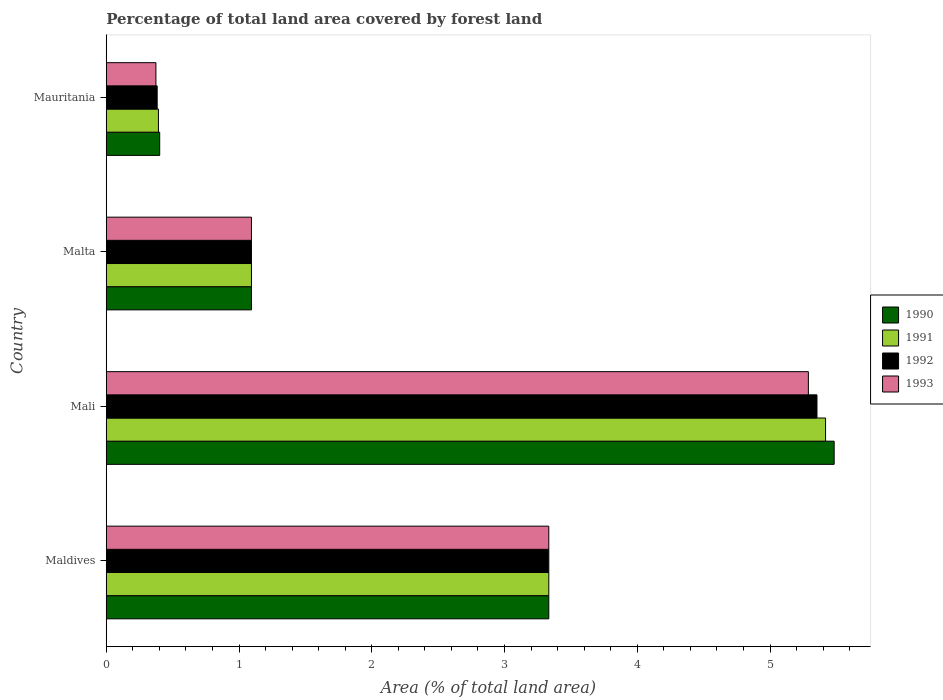How many different coloured bars are there?
Provide a short and direct response. 4. How many groups of bars are there?
Ensure brevity in your answer.  4. Are the number of bars per tick equal to the number of legend labels?
Offer a terse response. Yes. Are the number of bars on each tick of the Y-axis equal?
Give a very brief answer. Yes. How many bars are there on the 1st tick from the bottom?
Provide a succinct answer. 4. What is the label of the 3rd group of bars from the top?
Keep it short and to the point. Mali. In how many cases, is the number of bars for a given country not equal to the number of legend labels?
Provide a short and direct response. 0. What is the percentage of forest land in 1993 in Maldives?
Provide a succinct answer. 3.33. Across all countries, what is the maximum percentage of forest land in 1991?
Provide a short and direct response. 5.42. Across all countries, what is the minimum percentage of forest land in 1993?
Offer a terse response. 0.37. In which country was the percentage of forest land in 1992 maximum?
Provide a succinct answer. Mali. In which country was the percentage of forest land in 1992 minimum?
Ensure brevity in your answer.  Mauritania. What is the total percentage of forest land in 1993 in the graph?
Keep it short and to the point. 10.09. What is the difference between the percentage of forest land in 1990 in Maldives and that in Mauritania?
Make the answer very short. 2.93. What is the difference between the percentage of forest land in 1992 in Maldives and the percentage of forest land in 1990 in Mauritania?
Keep it short and to the point. 2.93. What is the average percentage of forest land in 1992 per country?
Your answer should be compact. 2.54. What is the difference between the percentage of forest land in 1993 and percentage of forest land in 1992 in Mali?
Your answer should be compact. -0.06. In how many countries, is the percentage of forest land in 1991 greater than 3.8 %?
Your answer should be compact. 1. What is the ratio of the percentage of forest land in 1992 in Malta to that in Mauritania?
Ensure brevity in your answer.  2.85. Is the percentage of forest land in 1992 in Maldives less than that in Mauritania?
Your answer should be compact. No. What is the difference between the highest and the second highest percentage of forest land in 1992?
Keep it short and to the point. 2.02. What is the difference between the highest and the lowest percentage of forest land in 1993?
Provide a short and direct response. 4.91. Is the sum of the percentage of forest land in 1992 in Mali and Malta greater than the maximum percentage of forest land in 1991 across all countries?
Provide a short and direct response. Yes. What does the 3rd bar from the top in Mali represents?
Make the answer very short. 1991. How many bars are there?
Give a very brief answer. 16. Are all the bars in the graph horizontal?
Your answer should be compact. Yes. What is the difference between two consecutive major ticks on the X-axis?
Your response must be concise. 1. Are the values on the major ticks of X-axis written in scientific E-notation?
Ensure brevity in your answer.  No. Does the graph contain grids?
Give a very brief answer. No. How many legend labels are there?
Ensure brevity in your answer.  4. How are the legend labels stacked?
Your answer should be compact. Vertical. What is the title of the graph?
Give a very brief answer. Percentage of total land area covered by forest land. Does "1970" appear as one of the legend labels in the graph?
Offer a very short reply. No. What is the label or title of the X-axis?
Give a very brief answer. Area (% of total land area). What is the label or title of the Y-axis?
Make the answer very short. Country. What is the Area (% of total land area) of 1990 in Maldives?
Make the answer very short. 3.33. What is the Area (% of total land area) in 1991 in Maldives?
Offer a very short reply. 3.33. What is the Area (% of total land area) of 1992 in Maldives?
Make the answer very short. 3.33. What is the Area (% of total land area) of 1993 in Maldives?
Provide a succinct answer. 3.33. What is the Area (% of total land area) in 1990 in Mali?
Keep it short and to the point. 5.48. What is the Area (% of total land area) in 1991 in Mali?
Keep it short and to the point. 5.42. What is the Area (% of total land area) in 1992 in Mali?
Your response must be concise. 5.35. What is the Area (% of total land area) in 1993 in Mali?
Offer a terse response. 5.29. What is the Area (% of total land area) of 1990 in Malta?
Your answer should be very brief. 1.09. What is the Area (% of total land area) in 1991 in Malta?
Give a very brief answer. 1.09. What is the Area (% of total land area) in 1992 in Malta?
Give a very brief answer. 1.09. What is the Area (% of total land area) in 1993 in Malta?
Offer a terse response. 1.09. What is the Area (% of total land area) of 1990 in Mauritania?
Ensure brevity in your answer.  0.4. What is the Area (% of total land area) in 1991 in Mauritania?
Make the answer very short. 0.39. What is the Area (% of total land area) in 1992 in Mauritania?
Ensure brevity in your answer.  0.38. What is the Area (% of total land area) of 1993 in Mauritania?
Keep it short and to the point. 0.37. Across all countries, what is the maximum Area (% of total land area) of 1990?
Offer a terse response. 5.48. Across all countries, what is the maximum Area (% of total land area) in 1991?
Provide a succinct answer. 5.42. Across all countries, what is the maximum Area (% of total land area) of 1992?
Make the answer very short. 5.35. Across all countries, what is the maximum Area (% of total land area) of 1993?
Keep it short and to the point. 5.29. Across all countries, what is the minimum Area (% of total land area) in 1990?
Offer a terse response. 0.4. Across all countries, what is the minimum Area (% of total land area) of 1991?
Offer a terse response. 0.39. Across all countries, what is the minimum Area (% of total land area) of 1992?
Offer a terse response. 0.38. Across all countries, what is the minimum Area (% of total land area) of 1993?
Your answer should be compact. 0.37. What is the total Area (% of total land area) of 1990 in the graph?
Provide a succinct answer. 10.31. What is the total Area (% of total land area) of 1991 in the graph?
Ensure brevity in your answer.  10.24. What is the total Area (% of total land area) in 1992 in the graph?
Keep it short and to the point. 10.16. What is the total Area (% of total land area) in 1993 in the graph?
Offer a terse response. 10.09. What is the difference between the Area (% of total land area) of 1990 in Maldives and that in Mali?
Keep it short and to the point. -2.15. What is the difference between the Area (% of total land area) of 1991 in Maldives and that in Mali?
Offer a terse response. -2.08. What is the difference between the Area (% of total land area) of 1992 in Maldives and that in Mali?
Offer a terse response. -2.02. What is the difference between the Area (% of total land area) of 1993 in Maldives and that in Mali?
Ensure brevity in your answer.  -1.96. What is the difference between the Area (% of total land area) of 1990 in Maldives and that in Malta?
Make the answer very short. 2.24. What is the difference between the Area (% of total land area) of 1991 in Maldives and that in Malta?
Make the answer very short. 2.24. What is the difference between the Area (% of total land area) of 1992 in Maldives and that in Malta?
Provide a short and direct response. 2.24. What is the difference between the Area (% of total land area) in 1993 in Maldives and that in Malta?
Make the answer very short. 2.24. What is the difference between the Area (% of total land area) in 1990 in Maldives and that in Mauritania?
Your answer should be very brief. 2.93. What is the difference between the Area (% of total land area) of 1991 in Maldives and that in Mauritania?
Make the answer very short. 2.94. What is the difference between the Area (% of total land area) in 1992 in Maldives and that in Mauritania?
Offer a terse response. 2.95. What is the difference between the Area (% of total land area) of 1993 in Maldives and that in Mauritania?
Give a very brief answer. 2.96. What is the difference between the Area (% of total land area) in 1990 in Mali and that in Malta?
Offer a very short reply. 4.39. What is the difference between the Area (% of total land area) in 1991 in Mali and that in Malta?
Keep it short and to the point. 4.32. What is the difference between the Area (% of total land area) in 1992 in Mali and that in Malta?
Offer a terse response. 4.26. What is the difference between the Area (% of total land area) of 1993 in Mali and that in Malta?
Ensure brevity in your answer.  4.19. What is the difference between the Area (% of total land area) in 1990 in Mali and that in Mauritania?
Give a very brief answer. 5.08. What is the difference between the Area (% of total land area) in 1991 in Mali and that in Mauritania?
Provide a succinct answer. 5.02. What is the difference between the Area (% of total land area) of 1992 in Mali and that in Mauritania?
Provide a succinct answer. 4.97. What is the difference between the Area (% of total land area) of 1993 in Mali and that in Mauritania?
Offer a terse response. 4.91. What is the difference between the Area (% of total land area) of 1990 in Malta and that in Mauritania?
Keep it short and to the point. 0.69. What is the difference between the Area (% of total land area) of 1991 in Malta and that in Mauritania?
Make the answer very short. 0.7. What is the difference between the Area (% of total land area) of 1992 in Malta and that in Mauritania?
Provide a short and direct response. 0.71. What is the difference between the Area (% of total land area) of 1993 in Malta and that in Mauritania?
Offer a terse response. 0.72. What is the difference between the Area (% of total land area) of 1990 in Maldives and the Area (% of total land area) of 1991 in Mali?
Offer a very short reply. -2.08. What is the difference between the Area (% of total land area) in 1990 in Maldives and the Area (% of total land area) in 1992 in Mali?
Give a very brief answer. -2.02. What is the difference between the Area (% of total land area) of 1990 in Maldives and the Area (% of total land area) of 1993 in Mali?
Give a very brief answer. -1.96. What is the difference between the Area (% of total land area) in 1991 in Maldives and the Area (% of total land area) in 1992 in Mali?
Ensure brevity in your answer.  -2.02. What is the difference between the Area (% of total land area) in 1991 in Maldives and the Area (% of total land area) in 1993 in Mali?
Offer a terse response. -1.96. What is the difference between the Area (% of total land area) of 1992 in Maldives and the Area (% of total land area) of 1993 in Mali?
Your response must be concise. -1.96. What is the difference between the Area (% of total land area) of 1990 in Maldives and the Area (% of total land area) of 1991 in Malta?
Ensure brevity in your answer.  2.24. What is the difference between the Area (% of total land area) of 1990 in Maldives and the Area (% of total land area) of 1992 in Malta?
Your answer should be very brief. 2.24. What is the difference between the Area (% of total land area) of 1990 in Maldives and the Area (% of total land area) of 1993 in Malta?
Make the answer very short. 2.24. What is the difference between the Area (% of total land area) of 1991 in Maldives and the Area (% of total land area) of 1992 in Malta?
Your answer should be very brief. 2.24. What is the difference between the Area (% of total land area) of 1991 in Maldives and the Area (% of total land area) of 1993 in Malta?
Offer a terse response. 2.24. What is the difference between the Area (% of total land area) of 1992 in Maldives and the Area (% of total land area) of 1993 in Malta?
Your answer should be compact. 2.24. What is the difference between the Area (% of total land area) of 1990 in Maldives and the Area (% of total land area) of 1991 in Mauritania?
Offer a very short reply. 2.94. What is the difference between the Area (% of total land area) of 1990 in Maldives and the Area (% of total land area) of 1992 in Mauritania?
Ensure brevity in your answer.  2.95. What is the difference between the Area (% of total land area) of 1990 in Maldives and the Area (% of total land area) of 1993 in Mauritania?
Provide a succinct answer. 2.96. What is the difference between the Area (% of total land area) in 1991 in Maldives and the Area (% of total land area) in 1992 in Mauritania?
Ensure brevity in your answer.  2.95. What is the difference between the Area (% of total land area) of 1991 in Maldives and the Area (% of total land area) of 1993 in Mauritania?
Offer a terse response. 2.96. What is the difference between the Area (% of total land area) of 1992 in Maldives and the Area (% of total land area) of 1993 in Mauritania?
Offer a terse response. 2.96. What is the difference between the Area (% of total land area) in 1990 in Mali and the Area (% of total land area) in 1991 in Malta?
Offer a terse response. 4.39. What is the difference between the Area (% of total land area) of 1990 in Mali and the Area (% of total land area) of 1992 in Malta?
Ensure brevity in your answer.  4.39. What is the difference between the Area (% of total land area) of 1990 in Mali and the Area (% of total land area) of 1993 in Malta?
Your answer should be compact. 4.39. What is the difference between the Area (% of total land area) in 1991 in Mali and the Area (% of total land area) in 1992 in Malta?
Make the answer very short. 4.32. What is the difference between the Area (% of total land area) of 1991 in Mali and the Area (% of total land area) of 1993 in Malta?
Keep it short and to the point. 4.32. What is the difference between the Area (% of total land area) of 1992 in Mali and the Area (% of total land area) of 1993 in Malta?
Ensure brevity in your answer.  4.26. What is the difference between the Area (% of total land area) in 1990 in Mali and the Area (% of total land area) in 1991 in Mauritania?
Your answer should be very brief. 5.09. What is the difference between the Area (% of total land area) of 1990 in Mali and the Area (% of total land area) of 1992 in Mauritania?
Your answer should be very brief. 5.1. What is the difference between the Area (% of total land area) in 1990 in Mali and the Area (% of total land area) in 1993 in Mauritania?
Ensure brevity in your answer.  5.11. What is the difference between the Area (% of total land area) of 1991 in Mali and the Area (% of total land area) of 1992 in Mauritania?
Your answer should be compact. 5.03. What is the difference between the Area (% of total land area) in 1991 in Mali and the Area (% of total land area) in 1993 in Mauritania?
Make the answer very short. 5.04. What is the difference between the Area (% of total land area) in 1992 in Mali and the Area (% of total land area) in 1993 in Mauritania?
Your answer should be compact. 4.98. What is the difference between the Area (% of total land area) in 1990 in Malta and the Area (% of total land area) in 1991 in Mauritania?
Make the answer very short. 0.7. What is the difference between the Area (% of total land area) in 1990 in Malta and the Area (% of total land area) in 1992 in Mauritania?
Your answer should be very brief. 0.71. What is the difference between the Area (% of total land area) in 1990 in Malta and the Area (% of total land area) in 1993 in Mauritania?
Provide a short and direct response. 0.72. What is the difference between the Area (% of total land area) in 1991 in Malta and the Area (% of total land area) in 1992 in Mauritania?
Your answer should be very brief. 0.71. What is the difference between the Area (% of total land area) in 1991 in Malta and the Area (% of total land area) in 1993 in Mauritania?
Keep it short and to the point. 0.72. What is the difference between the Area (% of total land area) of 1992 in Malta and the Area (% of total land area) of 1993 in Mauritania?
Your answer should be compact. 0.72. What is the average Area (% of total land area) of 1990 per country?
Offer a terse response. 2.58. What is the average Area (% of total land area) of 1991 per country?
Your answer should be compact. 2.56. What is the average Area (% of total land area) in 1992 per country?
Offer a terse response. 2.54. What is the average Area (% of total land area) of 1993 per country?
Provide a succinct answer. 2.52. What is the difference between the Area (% of total land area) of 1990 and Area (% of total land area) of 1991 in Maldives?
Ensure brevity in your answer.  0. What is the difference between the Area (% of total land area) in 1990 and Area (% of total land area) in 1992 in Maldives?
Offer a terse response. 0. What is the difference between the Area (% of total land area) in 1990 and Area (% of total land area) in 1993 in Maldives?
Make the answer very short. 0. What is the difference between the Area (% of total land area) of 1992 and Area (% of total land area) of 1993 in Maldives?
Give a very brief answer. 0. What is the difference between the Area (% of total land area) of 1990 and Area (% of total land area) of 1991 in Mali?
Offer a very short reply. 0.06. What is the difference between the Area (% of total land area) in 1990 and Area (% of total land area) in 1992 in Mali?
Make the answer very short. 0.13. What is the difference between the Area (% of total land area) of 1990 and Area (% of total land area) of 1993 in Mali?
Your answer should be compact. 0.19. What is the difference between the Area (% of total land area) in 1991 and Area (% of total land area) in 1992 in Mali?
Provide a succinct answer. 0.06. What is the difference between the Area (% of total land area) in 1991 and Area (% of total land area) in 1993 in Mali?
Your answer should be very brief. 0.13. What is the difference between the Area (% of total land area) in 1992 and Area (% of total land area) in 1993 in Mali?
Make the answer very short. 0.06. What is the difference between the Area (% of total land area) of 1990 and Area (% of total land area) of 1992 in Malta?
Offer a terse response. 0. What is the difference between the Area (% of total land area) of 1990 and Area (% of total land area) of 1991 in Mauritania?
Make the answer very short. 0.01. What is the difference between the Area (% of total land area) in 1990 and Area (% of total land area) in 1992 in Mauritania?
Keep it short and to the point. 0.02. What is the difference between the Area (% of total land area) in 1990 and Area (% of total land area) in 1993 in Mauritania?
Make the answer very short. 0.03. What is the difference between the Area (% of total land area) in 1991 and Area (% of total land area) in 1992 in Mauritania?
Make the answer very short. 0.01. What is the difference between the Area (% of total land area) of 1991 and Area (% of total land area) of 1993 in Mauritania?
Your answer should be compact. 0.02. What is the difference between the Area (% of total land area) in 1992 and Area (% of total land area) in 1993 in Mauritania?
Give a very brief answer. 0.01. What is the ratio of the Area (% of total land area) of 1990 in Maldives to that in Mali?
Keep it short and to the point. 0.61. What is the ratio of the Area (% of total land area) in 1991 in Maldives to that in Mali?
Make the answer very short. 0.62. What is the ratio of the Area (% of total land area) of 1992 in Maldives to that in Mali?
Your response must be concise. 0.62. What is the ratio of the Area (% of total land area) of 1993 in Maldives to that in Mali?
Offer a very short reply. 0.63. What is the ratio of the Area (% of total land area) in 1990 in Maldives to that in Malta?
Offer a very short reply. 3.05. What is the ratio of the Area (% of total land area) of 1991 in Maldives to that in Malta?
Offer a terse response. 3.05. What is the ratio of the Area (% of total land area) of 1992 in Maldives to that in Malta?
Your answer should be compact. 3.05. What is the ratio of the Area (% of total land area) in 1993 in Maldives to that in Malta?
Make the answer very short. 3.05. What is the ratio of the Area (% of total land area) in 1990 in Maldives to that in Mauritania?
Offer a terse response. 8.28. What is the ratio of the Area (% of total land area) of 1991 in Maldives to that in Mauritania?
Provide a succinct answer. 8.48. What is the ratio of the Area (% of total land area) in 1992 in Maldives to that in Mauritania?
Your answer should be compact. 8.69. What is the ratio of the Area (% of total land area) of 1993 in Maldives to that in Mauritania?
Your answer should be compact. 8.91. What is the ratio of the Area (% of total land area) in 1990 in Mali to that in Malta?
Provide a short and direct response. 5.01. What is the ratio of the Area (% of total land area) in 1991 in Mali to that in Malta?
Offer a very short reply. 4.95. What is the ratio of the Area (% of total land area) of 1992 in Mali to that in Malta?
Make the answer very short. 4.89. What is the ratio of the Area (% of total land area) of 1993 in Mali to that in Malta?
Your response must be concise. 4.84. What is the ratio of the Area (% of total land area) of 1990 in Mali to that in Mauritania?
Keep it short and to the point. 13.62. What is the ratio of the Area (% of total land area) of 1991 in Mali to that in Mauritania?
Your response must be concise. 13.78. What is the ratio of the Area (% of total land area) in 1992 in Mali to that in Mauritania?
Your answer should be compact. 13.95. What is the ratio of the Area (% of total land area) in 1993 in Mali to that in Mauritania?
Keep it short and to the point. 14.14. What is the ratio of the Area (% of total land area) of 1990 in Malta to that in Mauritania?
Your response must be concise. 2.72. What is the ratio of the Area (% of total land area) of 1991 in Malta to that in Mauritania?
Your response must be concise. 2.78. What is the ratio of the Area (% of total land area) of 1992 in Malta to that in Mauritania?
Your answer should be compact. 2.85. What is the ratio of the Area (% of total land area) of 1993 in Malta to that in Mauritania?
Offer a terse response. 2.92. What is the difference between the highest and the second highest Area (% of total land area) in 1990?
Give a very brief answer. 2.15. What is the difference between the highest and the second highest Area (% of total land area) of 1991?
Your response must be concise. 2.08. What is the difference between the highest and the second highest Area (% of total land area) in 1992?
Provide a succinct answer. 2.02. What is the difference between the highest and the second highest Area (% of total land area) of 1993?
Your response must be concise. 1.96. What is the difference between the highest and the lowest Area (% of total land area) in 1990?
Ensure brevity in your answer.  5.08. What is the difference between the highest and the lowest Area (% of total land area) of 1991?
Provide a succinct answer. 5.02. What is the difference between the highest and the lowest Area (% of total land area) of 1992?
Your answer should be compact. 4.97. What is the difference between the highest and the lowest Area (% of total land area) in 1993?
Your answer should be compact. 4.91. 